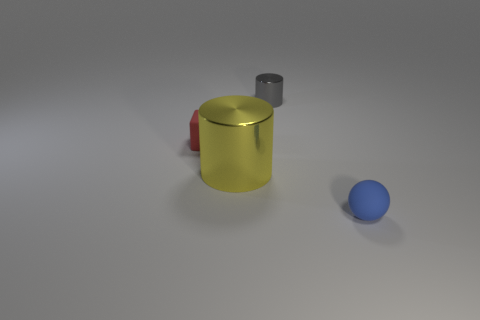There is a blue ball that is the same size as the gray cylinder; what is it made of?
Provide a short and direct response. Rubber. Is the material of the tiny cylinder the same as the tiny block?
Keep it short and to the point. No. What color is the thing that is in front of the small red thing and on the left side of the gray cylinder?
Give a very brief answer. Yellow. Does the metal cylinder that is in front of the gray shiny cylinder have the same color as the small cube?
Give a very brief answer. No. The gray metal object that is the same size as the red thing is what shape?
Keep it short and to the point. Cylinder. How many other things are there of the same color as the tiny metallic cylinder?
Provide a short and direct response. 0. What number of other things are the same material as the gray cylinder?
Keep it short and to the point. 1. There is a ball; is it the same size as the metallic cylinder that is behind the small red rubber block?
Provide a succinct answer. Yes. What color is the small cylinder?
Make the answer very short. Gray. There is a rubber object behind the tiny matte thing that is on the right side of the cylinder behind the large yellow cylinder; what shape is it?
Give a very brief answer. Cube. 